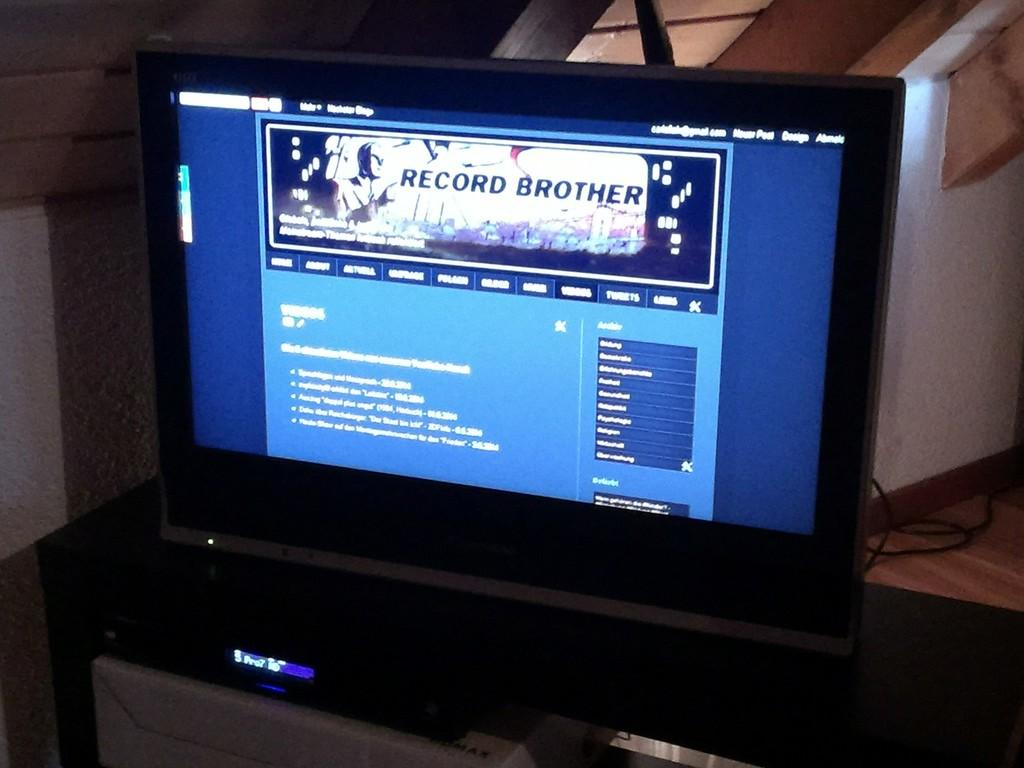<image>
Create a compact narrative representing the image presented. The new post button is located on the top right. 